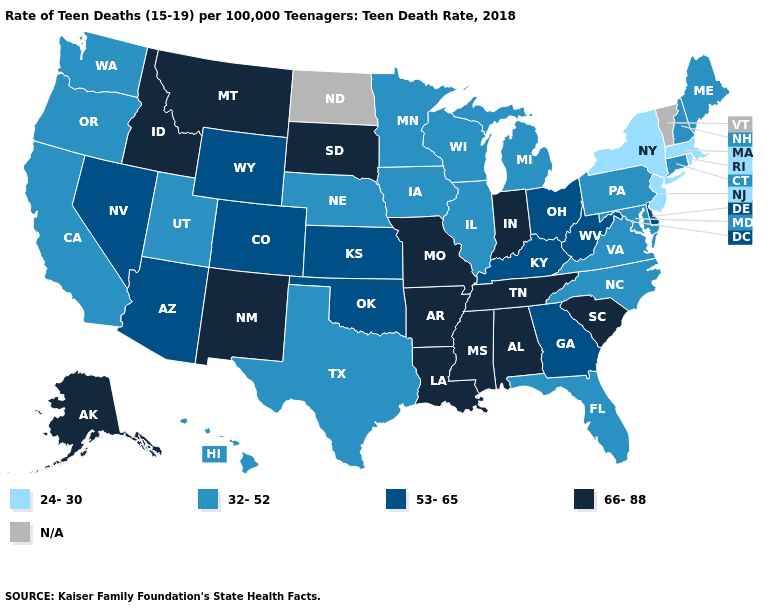Among the states that border Mississippi , which have the highest value?
Keep it brief. Alabama, Arkansas, Louisiana, Tennessee. What is the value of Rhode Island?
Short answer required. 24-30. Name the states that have a value in the range 32-52?
Quick response, please. California, Connecticut, Florida, Hawaii, Illinois, Iowa, Maine, Maryland, Michigan, Minnesota, Nebraska, New Hampshire, North Carolina, Oregon, Pennsylvania, Texas, Utah, Virginia, Washington, Wisconsin. Which states hav the highest value in the MidWest?
Quick response, please. Indiana, Missouri, South Dakota. Is the legend a continuous bar?
Answer briefly. No. What is the value of Idaho?
Keep it brief. 66-88. Does North Carolina have the highest value in the USA?
Short answer required. No. Name the states that have a value in the range 66-88?
Write a very short answer. Alabama, Alaska, Arkansas, Idaho, Indiana, Louisiana, Mississippi, Missouri, Montana, New Mexico, South Carolina, South Dakota, Tennessee. Name the states that have a value in the range 32-52?
Concise answer only. California, Connecticut, Florida, Hawaii, Illinois, Iowa, Maine, Maryland, Michigan, Minnesota, Nebraska, New Hampshire, North Carolina, Oregon, Pennsylvania, Texas, Utah, Virginia, Washington, Wisconsin. Which states have the highest value in the USA?
Write a very short answer. Alabama, Alaska, Arkansas, Idaho, Indiana, Louisiana, Mississippi, Missouri, Montana, New Mexico, South Carolina, South Dakota, Tennessee. What is the value of Washington?
Write a very short answer. 32-52. Which states hav the highest value in the West?
Write a very short answer. Alaska, Idaho, Montana, New Mexico. What is the value of Vermont?
Write a very short answer. N/A. What is the highest value in the USA?
Keep it brief. 66-88. 